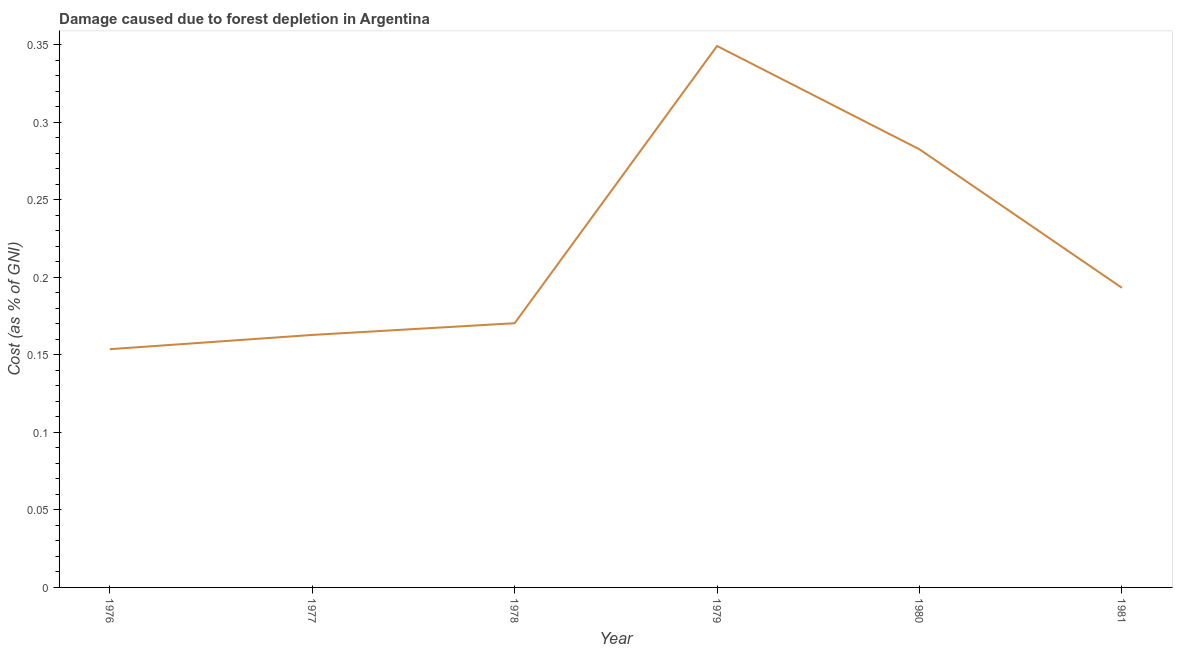What is the damage caused due to forest depletion in 1979?
Offer a very short reply. 0.35. Across all years, what is the maximum damage caused due to forest depletion?
Your answer should be very brief. 0.35. Across all years, what is the minimum damage caused due to forest depletion?
Your answer should be very brief. 0.15. In which year was the damage caused due to forest depletion maximum?
Offer a very short reply. 1979. In which year was the damage caused due to forest depletion minimum?
Offer a terse response. 1976. What is the sum of the damage caused due to forest depletion?
Make the answer very short. 1.31. What is the difference between the damage caused due to forest depletion in 1976 and 1977?
Your answer should be compact. -0.01. What is the average damage caused due to forest depletion per year?
Keep it short and to the point. 0.22. What is the median damage caused due to forest depletion?
Provide a short and direct response. 0.18. In how many years, is the damage caused due to forest depletion greater than 0.19000000000000003 %?
Give a very brief answer. 3. What is the ratio of the damage caused due to forest depletion in 1976 to that in 1980?
Offer a terse response. 0.54. What is the difference between the highest and the second highest damage caused due to forest depletion?
Offer a terse response. 0.07. What is the difference between the highest and the lowest damage caused due to forest depletion?
Your response must be concise. 0.2. In how many years, is the damage caused due to forest depletion greater than the average damage caused due to forest depletion taken over all years?
Provide a succinct answer. 2. Does the graph contain grids?
Provide a succinct answer. No. What is the title of the graph?
Your answer should be very brief. Damage caused due to forest depletion in Argentina. What is the label or title of the Y-axis?
Offer a terse response. Cost (as % of GNI). What is the Cost (as % of GNI) in 1976?
Give a very brief answer. 0.15. What is the Cost (as % of GNI) of 1977?
Keep it short and to the point. 0.16. What is the Cost (as % of GNI) of 1978?
Make the answer very short. 0.17. What is the Cost (as % of GNI) of 1979?
Provide a short and direct response. 0.35. What is the Cost (as % of GNI) of 1980?
Keep it short and to the point. 0.28. What is the Cost (as % of GNI) of 1981?
Your answer should be very brief. 0.19. What is the difference between the Cost (as % of GNI) in 1976 and 1977?
Provide a short and direct response. -0.01. What is the difference between the Cost (as % of GNI) in 1976 and 1978?
Your response must be concise. -0.02. What is the difference between the Cost (as % of GNI) in 1976 and 1979?
Offer a terse response. -0.2. What is the difference between the Cost (as % of GNI) in 1976 and 1980?
Ensure brevity in your answer.  -0.13. What is the difference between the Cost (as % of GNI) in 1976 and 1981?
Keep it short and to the point. -0.04. What is the difference between the Cost (as % of GNI) in 1977 and 1978?
Your response must be concise. -0.01. What is the difference between the Cost (as % of GNI) in 1977 and 1979?
Give a very brief answer. -0.19. What is the difference between the Cost (as % of GNI) in 1977 and 1980?
Give a very brief answer. -0.12. What is the difference between the Cost (as % of GNI) in 1977 and 1981?
Your answer should be compact. -0.03. What is the difference between the Cost (as % of GNI) in 1978 and 1979?
Offer a terse response. -0.18. What is the difference between the Cost (as % of GNI) in 1978 and 1980?
Offer a very short reply. -0.11. What is the difference between the Cost (as % of GNI) in 1978 and 1981?
Provide a succinct answer. -0.02. What is the difference between the Cost (as % of GNI) in 1979 and 1980?
Your answer should be very brief. 0.07. What is the difference between the Cost (as % of GNI) in 1979 and 1981?
Keep it short and to the point. 0.16. What is the difference between the Cost (as % of GNI) in 1980 and 1981?
Your answer should be compact. 0.09. What is the ratio of the Cost (as % of GNI) in 1976 to that in 1977?
Your answer should be very brief. 0.94. What is the ratio of the Cost (as % of GNI) in 1976 to that in 1978?
Give a very brief answer. 0.9. What is the ratio of the Cost (as % of GNI) in 1976 to that in 1979?
Ensure brevity in your answer.  0.44. What is the ratio of the Cost (as % of GNI) in 1976 to that in 1980?
Make the answer very short. 0.54. What is the ratio of the Cost (as % of GNI) in 1976 to that in 1981?
Give a very brief answer. 0.8. What is the ratio of the Cost (as % of GNI) in 1977 to that in 1978?
Your response must be concise. 0.96. What is the ratio of the Cost (as % of GNI) in 1977 to that in 1979?
Your response must be concise. 0.47. What is the ratio of the Cost (as % of GNI) in 1977 to that in 1980?
Provide a short and direct response. 0.58. What is the ratio of the Cost (as % of GNI) in 1977 to that in 1981?
Keep it short and to the point. 0.84. What is the ratio of the Cost (as % of GNI) in 1978 to that in 1979?
Provide a succinct answer. 0.49. What is the ratio of the Cost (as % of GNI) in 1978 to that in 1980?
Provide a succinct answer. 0.6. What is the ratio of the Cost (as % of GNI) in 1978 to that in 1981?
Your response must be concise. 0.88. What is the ratio of the Cost (as % of GNI) in 1979 to that in 1980?
Your answer should be very brief. 1.24. What is the ratio of the Cost (as % of GNI) in 1979 to that in 1981?
Offer a terse response. 1.81. What is the ratio of the Cost (as % of GNI) in 1980 to that in 1981?
Your answer should be compact. 1.46. 